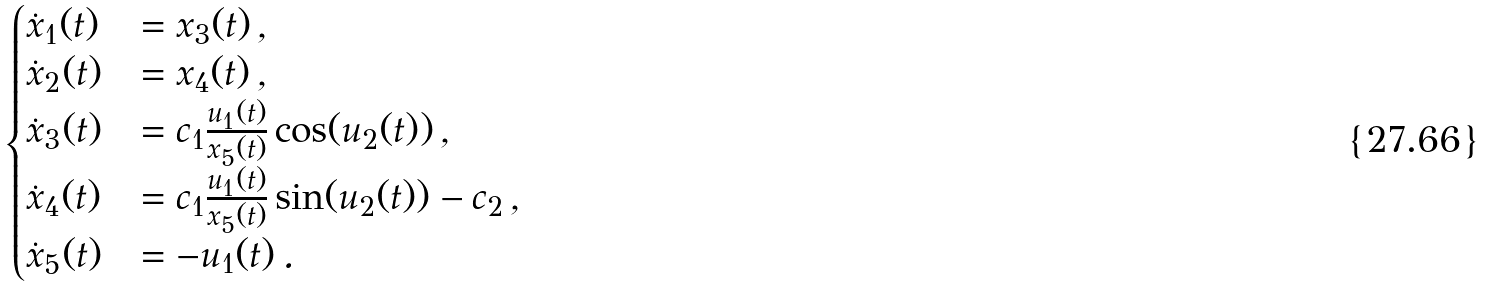Convert formula to latex. <formula><loc_0><loc_0><loc_500><loc_500>\begin{cases} \dot { x } _ { 1 } ( t ) & = x _ { 3 } ( t ) \, , \\ \dot { x } _ { 2 } ( t ) & = x _ { 4 } ( t ) \, , \\ \dot { x } _ { 3 } ( t ) & = c _ { 1 } \frac { u _ { 1 } ( t ) } { x _ { 5 } ( t ) } \cos ( u _ { 2 } ( t ) ) \, , \\ \dot { x } _ { 4 } ( t ) & = c _ { 1 } \frac { u _ { 1 } ( t ) } { x _ { 5 } ( t ) } \sin ( u _ { 2 } ( t ) ) - c _ { 2 } \, , \\ \dot { x } _ { 5 } ( t ) & = - u _ { 1 } ( t ) \, . \end{cases}</formula> 